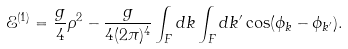Convert formula to latex. <formula><loc_0><loc_0><loc_500><loc_500>\mathcal { E } ^ { ( 1 ) } = \frac { g } { 4 } \rho ^ { 2 } - \frac { g } { 4 ( 2 \pi ) ^ { 4 } } \int _ { F } d k \int _ { F } d k ^ { \prime } \cos ( \phi _ { k } - \phi _ { k ^ { \prime } } ) .</formula> 